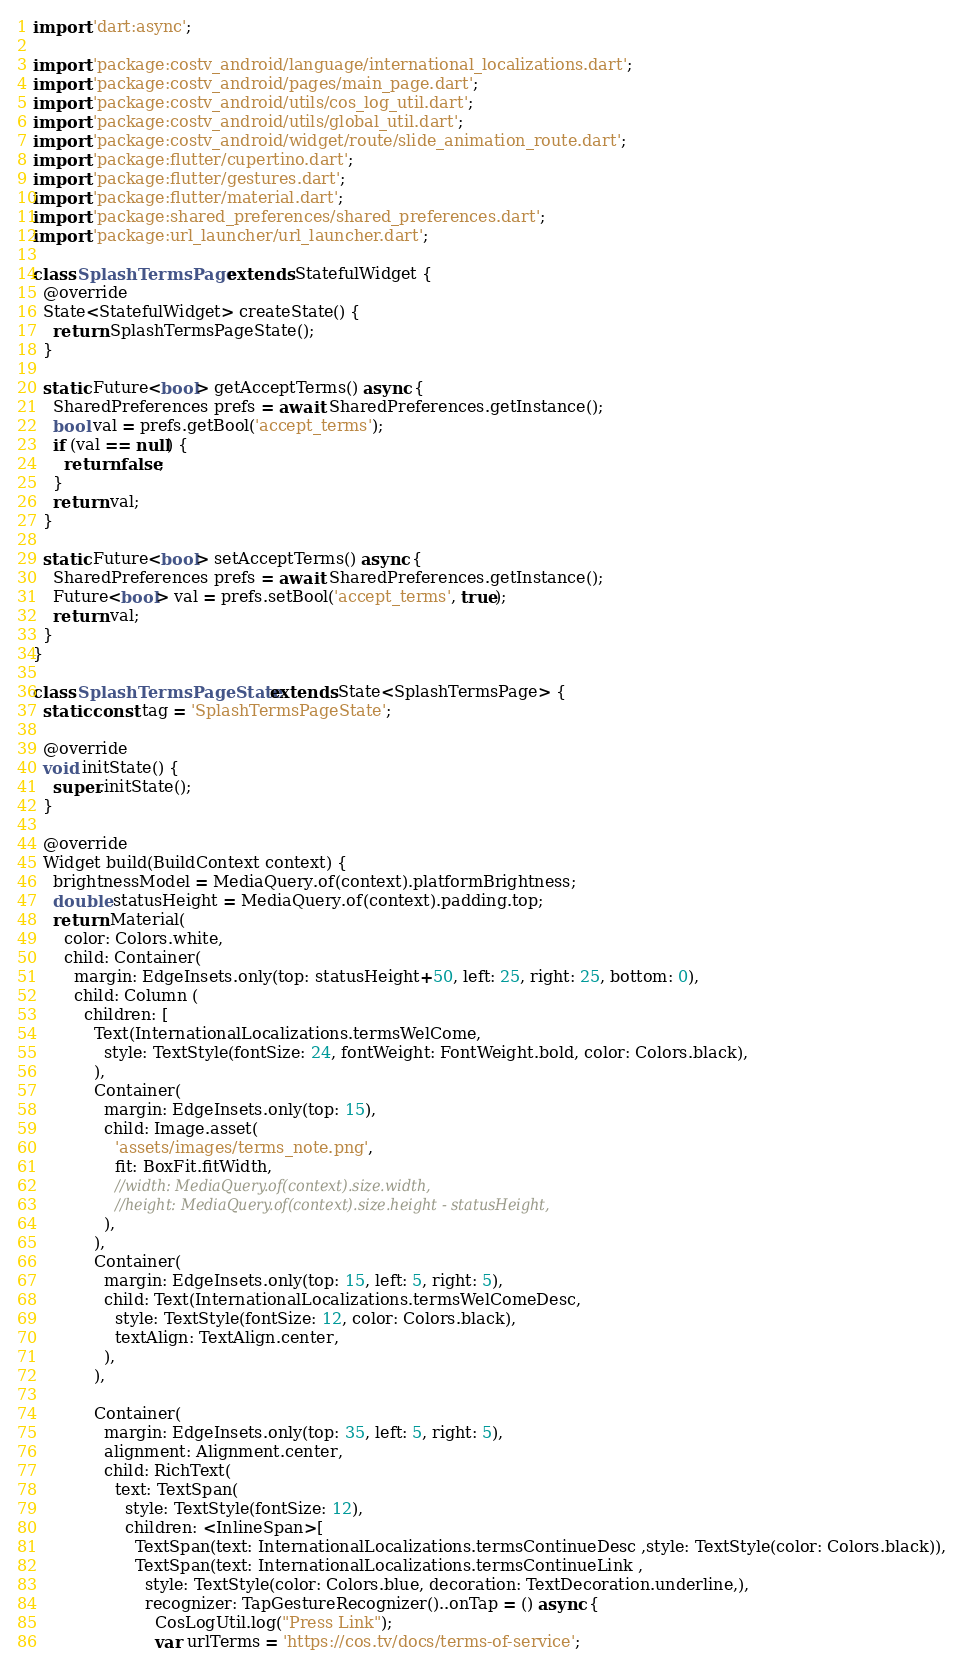<code> <loc_0><loc_0><loc_500><loc_500><_Dart_>import 'dart:async';

import 'package:costv_android/language/international_localizations.dart';
import 'package:costv_android/pages/main_page.dart';
import 'package:costv_android/utils/cos_log_util.dart';
import 'package:costv_android/utils/global_util.dart';
import 'package:costv_android/widget/route/slide_animation_route.dart';
import 'package:flutter/cupertino.dart';
import 'package:flutter/gestures.dart';
import 'package:flutter/material.dart';
import 'package:shared_preferences/shared_preferences.dart';
import 'package:url_launcher/url_launcher.dart';

class SplashTermsPage extends StatefulWidget {
  @override
  State<StatefulWidget> createState() {
    return SplashTermsPageState();
  }

  static Future<bool> getAcceptTerms() async {
    SharedPreferences prefs = await SharedPreferences.getInstance();
    bool val = prefs.getBool('accept_terms');
    if (val == null) {
      return false;
    }
    return val;
  }

  static Future<bool> setAcceptTerms() async {
    SharedPreferences prefs = await SharedPreferences.getInstance();
    Future<bool> val = prefs.setBool('accept_terms', true);
    return val;
  }
}

class SplashTermsPageState extends State<SplashTermsPage> {
  static const tag = 'SplashTermsPageState';

  @override
  void initState() {
    super.initState();
  }

  @override
  Widget build(BuildContext context) {
    brightnessModel = MediaQuery.of(context).platformBrightness;
    double statusHeight = MediaQuery.of(context).padding.top;
    return Material(
      color: Colors.white,
      child: Container(
        margin: EdgeInsets.only(top: statusHeight+50, left: 25, right: 25, bottom: 0),
        child: Column (
          children: [
            Text(InternationalLocalizations.termsWelCome,
              style: TextStyle(fontSize: 24, fontWeight: FontWeight.bold, color: Colors.black),
            ),
            Container(
              margin: EdgeInsets.only(top: 15),
              child: Image.asset(
                'assets/images/terms_note.png',
                fit: BoxFit.fitWidth,
                //width: MediaQuery.of(context).size.width,
                //height: MediaQuery.of(context).size.height - statusHeight,
              ),
            ),
            Container(
              margin: EdgeInsets.only(top: 15, left: 5, right: 5),
              child: Text(InternationalLocalizations.termsWelComeDesc,
                style: TextStyle(fontSize: 12, color: Colors.black),
                textAlign: TextAlign.center,
              ),
            ),
            
            Container(
              margin: EdgeInsets.only(top: 35, left: 5, right: 5),
              alignment: Alignment.center,
              child: RichText(
                text: TextSpan(
                  style: TextStyle(fontSize: 12),
                  children: <InlineSpan>[
                    TextSpan(text: InternationalLocalizations.termsContinueDesc ,style: TextStyle(color: Colors.black)),
                    TextSpan(text: InternationalLocalizations.termsContinueLink ,
                      style: TextStyle(color: Colors.blue, decoration: TextDecoration.underline,),
                      recognizer: TapGestureRecognizer()..onTap = () async {
                        CosLogUtil.log("Press Link");
                        var urlTerms = 'https://cos.tv/docs/terms-of-service';</code> 